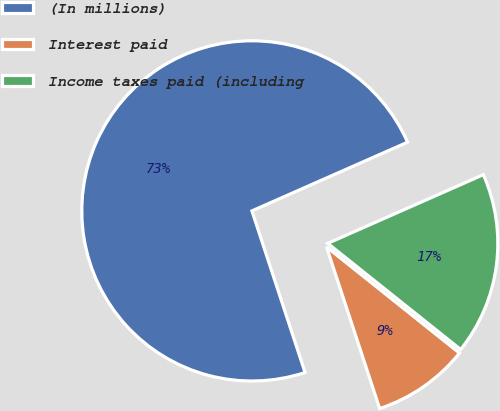<chart> <loc_0><loc_0><loc_500><loc_500><pie_chart><fcel>(In millions)<fcel>Interest paid<fcel>Income taxes paid (including<nl><fcel>73.45%<fcel>9.22%<fcel>17.34%<nl></chart> 